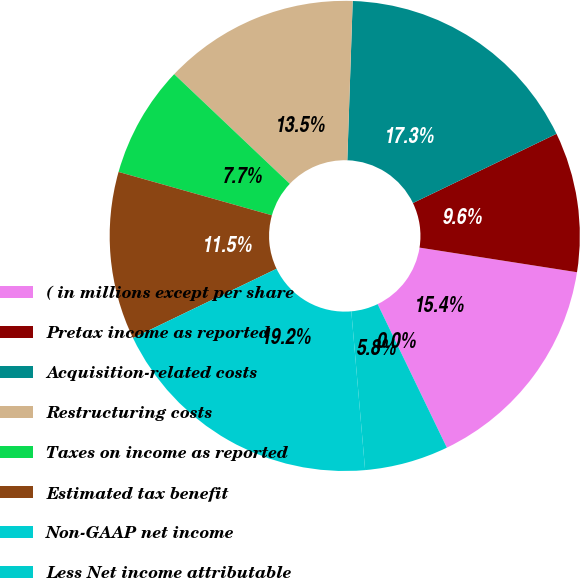Convert chart. <chart><loc_0><loc_0><loc_500><loc_500><pie_chart><fcel>( in millions except per share<fcel>Pretax income as reported<fcel>Acquisition-related costs<fcel>Restructuring costs<fcel>Taxes on income as reported<fcel>Estimated tax benefit<fcel>Non-GAAP net income<fcel>Less Net income attributable<fcel>EPS assuming dilution as<nl><fcel>15.38%<fcel>9.62%<fcel>17.31%<fcel>13.46%<fcel>7.69%<fcel>11.54%<fcel>19.23%<fcel>5.77%<fcel>0.0%<nl></chart> 